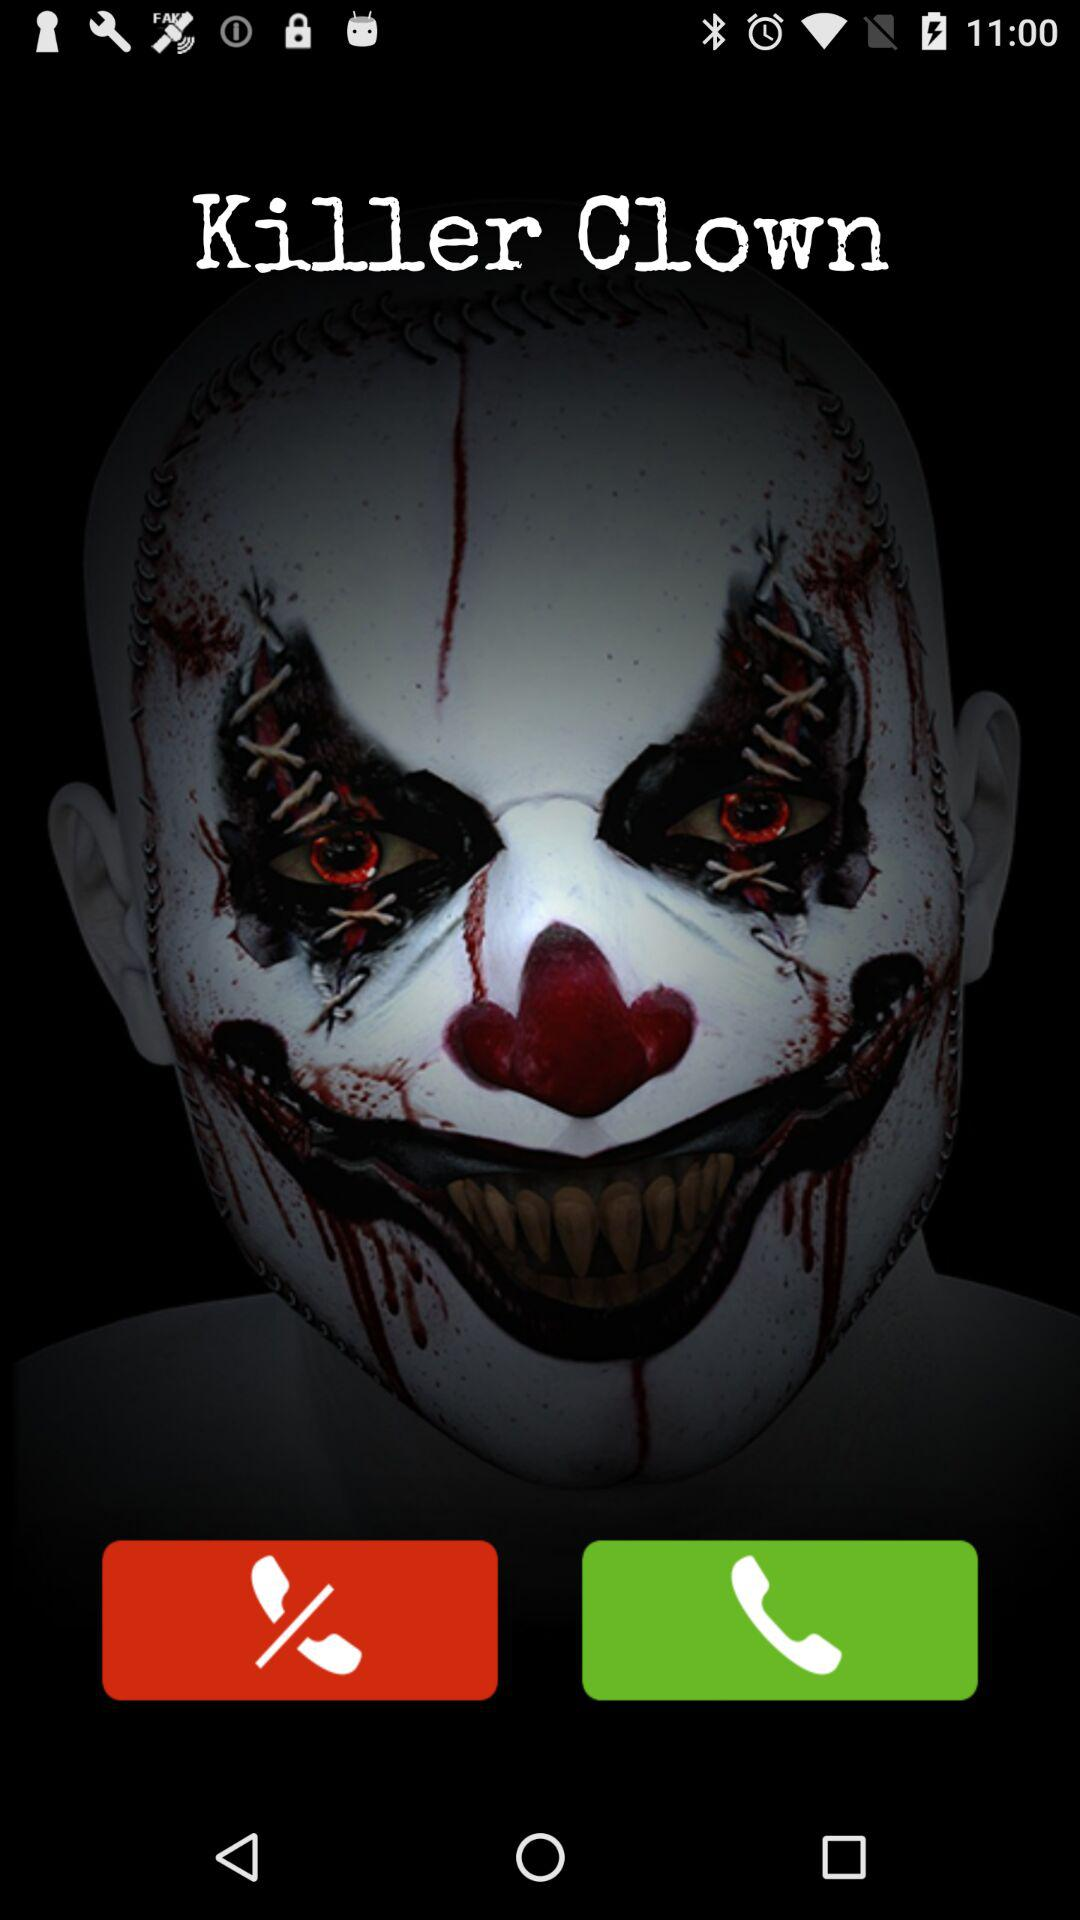Who is calling me? The person who is calling you is "Killer Clown". 